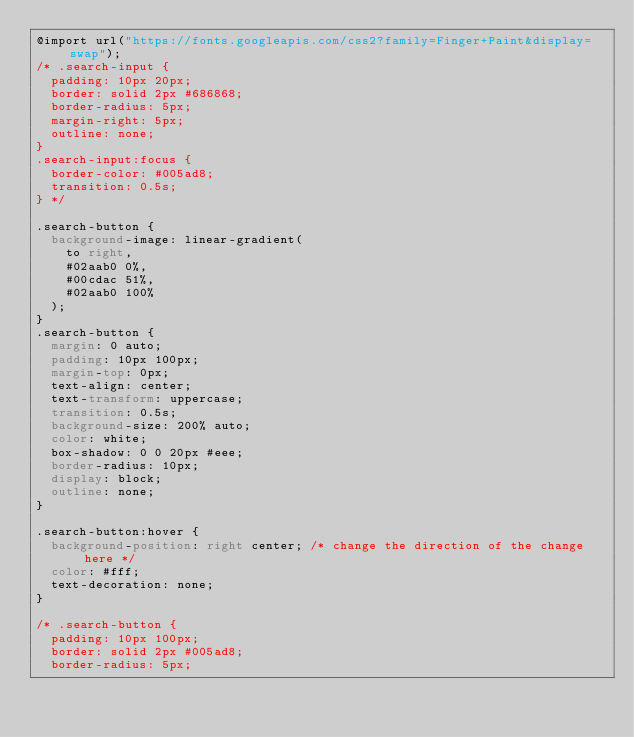Convert code to text. <code><loc_0><loc_0><loc_500><loc_500><_CSS_>@import url("https://fonts.googleapis.com/css2?family=Finger+Paint&display=swap");
/* .search-input {
  padding: 10px 20px;
  border: solid 2px #686868;
  border-radius: 5px;
  margin-right: 5px;
  outline: none;
}
.search-input:focus {
  border-color: #005ad8;
  transition: 0.5s;
} */

.search-button {
  background-image: linear-gradient(
    to right,
    #02aab0 0%,
    #00cdac 51%,
    #02aab0 100%
  );
}
.search-button {
  margin: 0 auto;
  padding: 10px 100px;
  margin-top: 0px;
  text-align: center;
  text-transform: uppercase;
  transition: 0.5s;
  background-size: 200% auto;
  color: white;
  box-shadow: 0 0 20px #eee;
  border-radius: 10px;
  display: block;
  outline: none;
}

.search-button:hover {
  background-position: right center; /* change the direction of the change here */
  color: #fff;
  text-decoration: none;
}

/* .search-button {
  padding: 10px 100px;
  border: solid 2px #005ad8;
  border-radius: 5px;</code> 